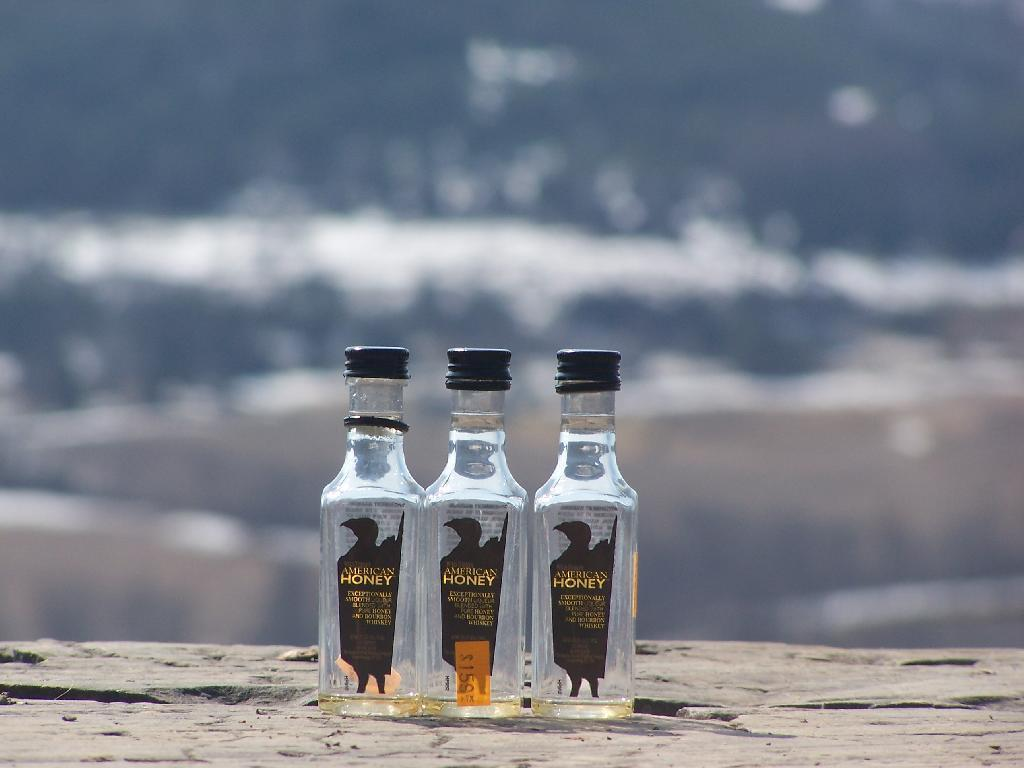<image>
Create a compact narrative representing the image presented. Three American Honey bottles in front of some waves. 